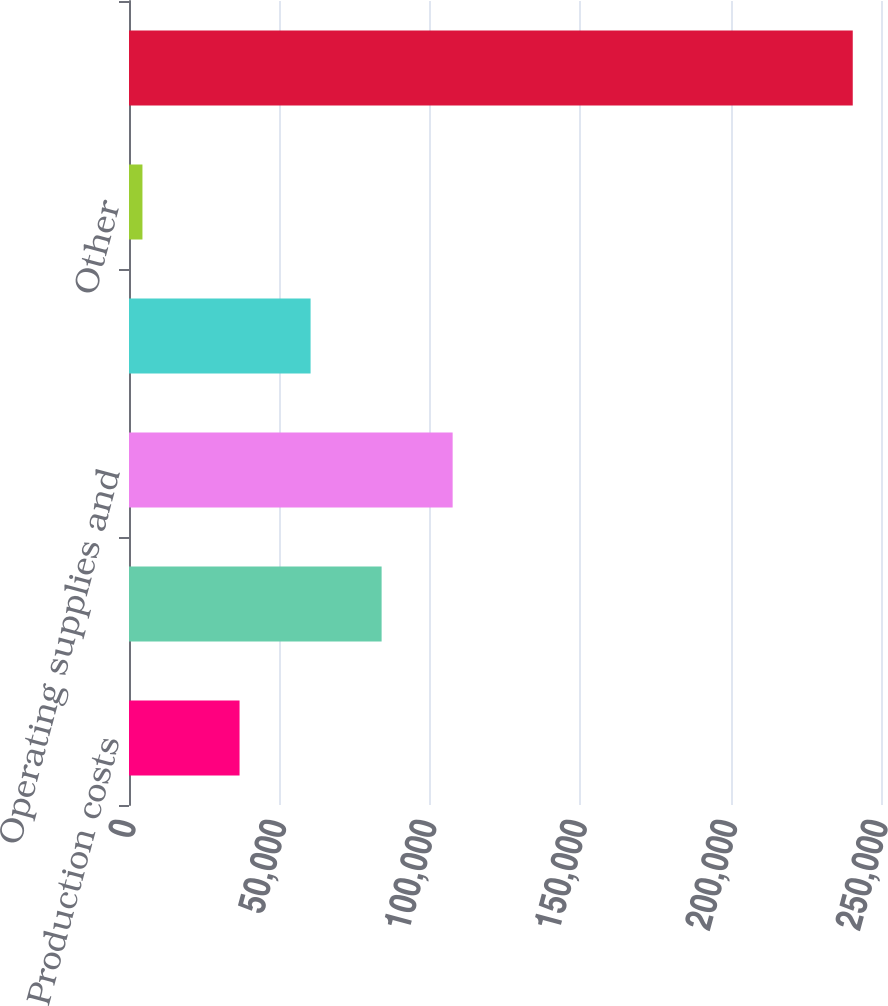<chart> <loc_0><loc_0><loc_500><loc_500><bar_chart><fcel>Production costs<fcel>Employee-related costs<fcel>Operating supplies and<fcel>Maintenance materials and<fcel>Other<fcel>Total<nl><fcel>36753<fcel>83980.8<fcel>107595<fcel>60366.9<fcel>4471<fcel>240610<nl></chart> 